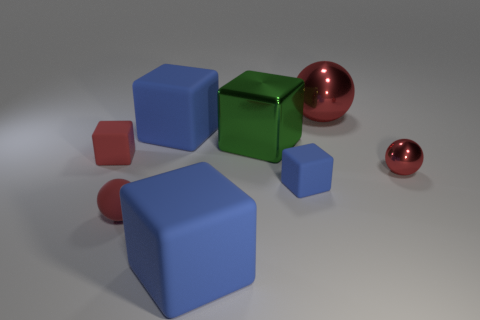Does the rubber ball have the same color as the big sphere?
Your response must be concise. Yes. The large matte thing that is behind the sphere on the left side of the red sphere that is behind the green block is what color?
Your response must be concise. Blue. Is the large green thing made of the same material as the small blue cube?
Give a very brief answer. No. What number of red objects are to the left of the tiny red metal thing?
Provide a succinct answer. 3. What size is the red rubber thing that is the same shape as the small red metallic object?
Your answer should be compact. Small. What number of red objects are tiny rubber blocks or metal things?
Offer a very short reply. 3. What number of matte blocks are in front of the red shiny ball that is in front of the large green metal block?
Make the answer very short. 2. How many other things are there of the same shape as the large green shiny object?
Keep it short and to the point. 4. There is a big thing that is the same color as the small shiny thing; what material is it?
Your answer should be very brief. Metal. What number of objects are the same color as the small matte ball?
Offer a terse response. 3. 